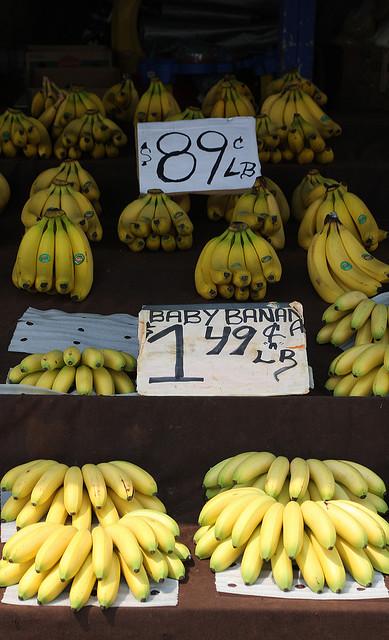Do these fruits grow in Northern Canada?
Write a very short answer. No. How much are the baby bananas?
Be succinct. 1.49 lb. Is that cheap?
Give a very brief answer. No. 